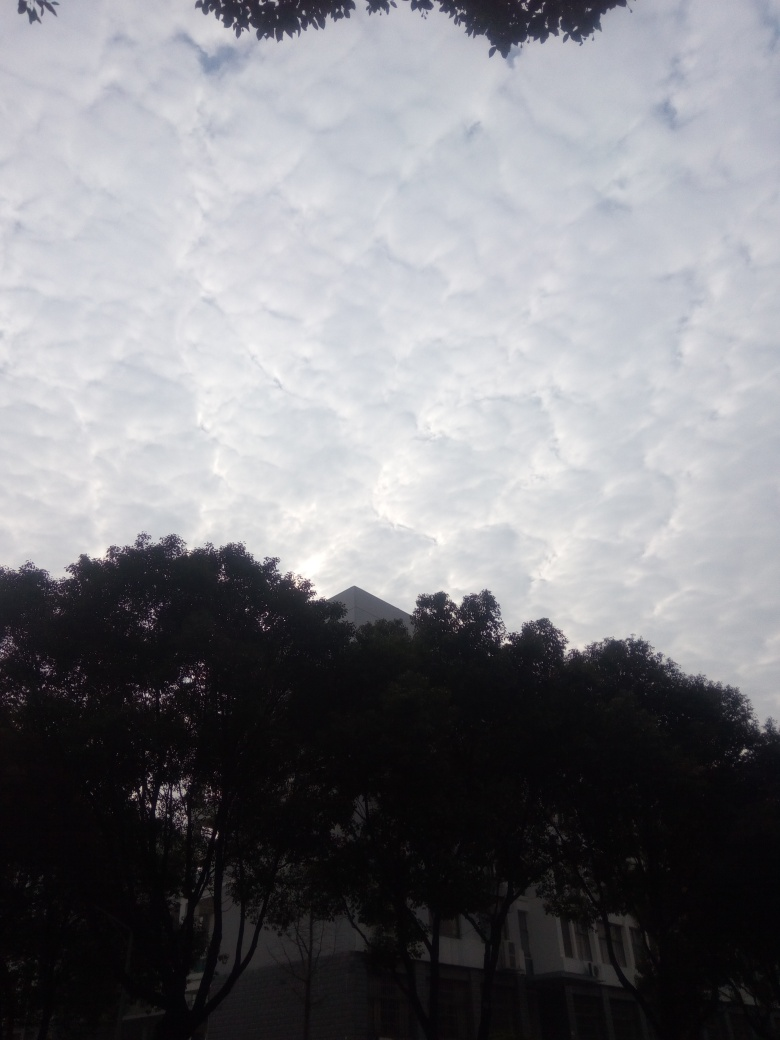Can you describe the weather conditions possibly indicated by the cloud formations in this image? The clouds in this image appear to be altocumulus, often present in stable air conditions and can precede a cold front, suggesting that mild weather was prevailing at the time. However, this type of cloud formation can also develop before a change in the weather, so it might be an indication of an upcoming weather shift. 